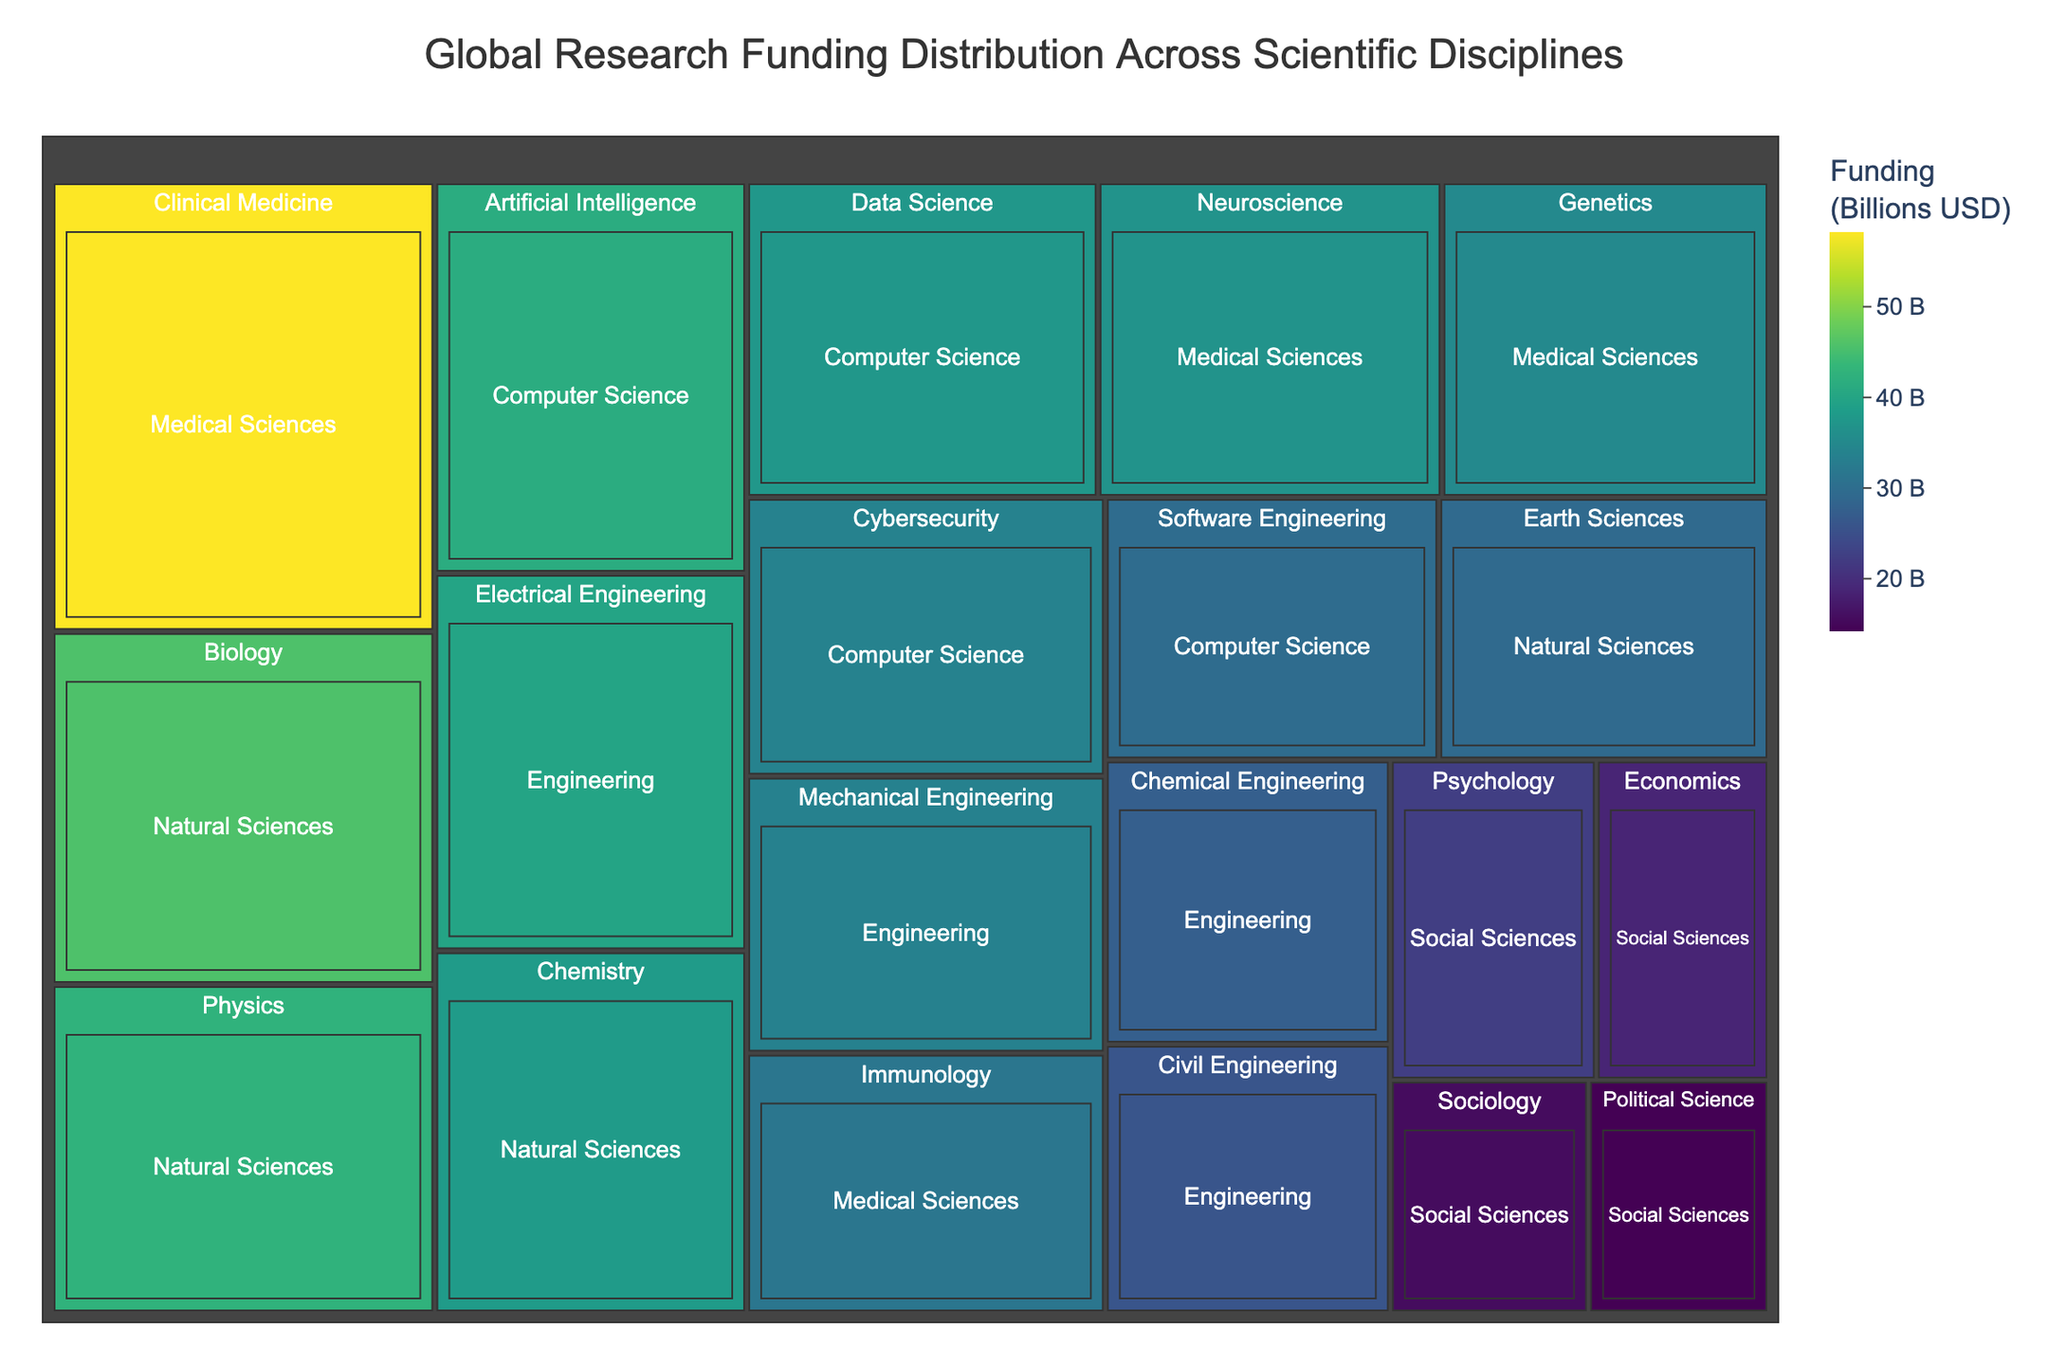Which scientific discipline category has the highest funding? The figure is divided into categories with funding amounts. Identifying the discipline with the largest area in the treemap would give the category with the highest funding.
Answer: Medical Sciences What is the total funding for Computer Science disciplines? Add up the funding for all sub-disciplines in the Computer Science category: Artificial Intelligence, Cybersecurity, Data Science, and Software Engineering. 41.3 + 33.8 + 37.5 + 29.6 = 142.2
Answer: 142.2 Billion USD Which discipline under Engineering has the least funding? Look for the rectangle with the smallest area and value under the Engineering category.
Answer: Civil Engineering How does the funding of Neuroscience compare to Electrical Engineering? Compare the funding values of Neuroscience (36.7 Billion USD) and Electrical Engineering (39.8 Billion USD). Electrical Engineering has more funding.
Answer: Electrical Engineering has more funding Rank the categories in Natural Sciences by their funding amount. List the Natural Sciences disciplines (Physics, Chemistry, Biology, and Earth Sciences) and order them by the funding values: Biology (45.7), Physics (42.5), Chemistry (38.2), Earth Sciences (29.3).
Answer: Biology > Physics > Chemistry > Earth Sciences Which category has the highest funding within Medical Sciences? Identify the category within the Medical Sciences with the highest funding value by comparing Clinical Medicine, Neuroscience, Immunology, and Genetics. The highest value is Clinical Medicine with 58.2 Billion USD.
Answer: Clinical Medicine What is the difference in funding between the highest and lowest funded disciplines in Social Sciences? Subtract the lowest funding in Social Sciences (Political Science, 14.2 Billion USD) from the highest funding (Psychology, 22.3 Billion USD). 22.3 - 14.2 = 8.1.
Answer: 8.1 Billion USD If you combine the total funding for all Engineering disciplines, how does it compare to the total funding for all Natural Sciences disciplines? Calculate the total funding for Engineering: 33.6 + 39.8 + 27.4 + 25.9 = 126.7. Calculate the total funding for Natural Sciences: 42.5 + 38.2 + 45.7 + 29.3 = 155.7. Compare the two totals.
Answer: Natural Sciences have more funding Which discipline has a funding value closest to 40 Billion USD? Find the discipline whose funding value is nearest to 40. The closest to 40 is Electrical Engineering with 39.8 Billion USD.
Answer: Electrical Engineering 